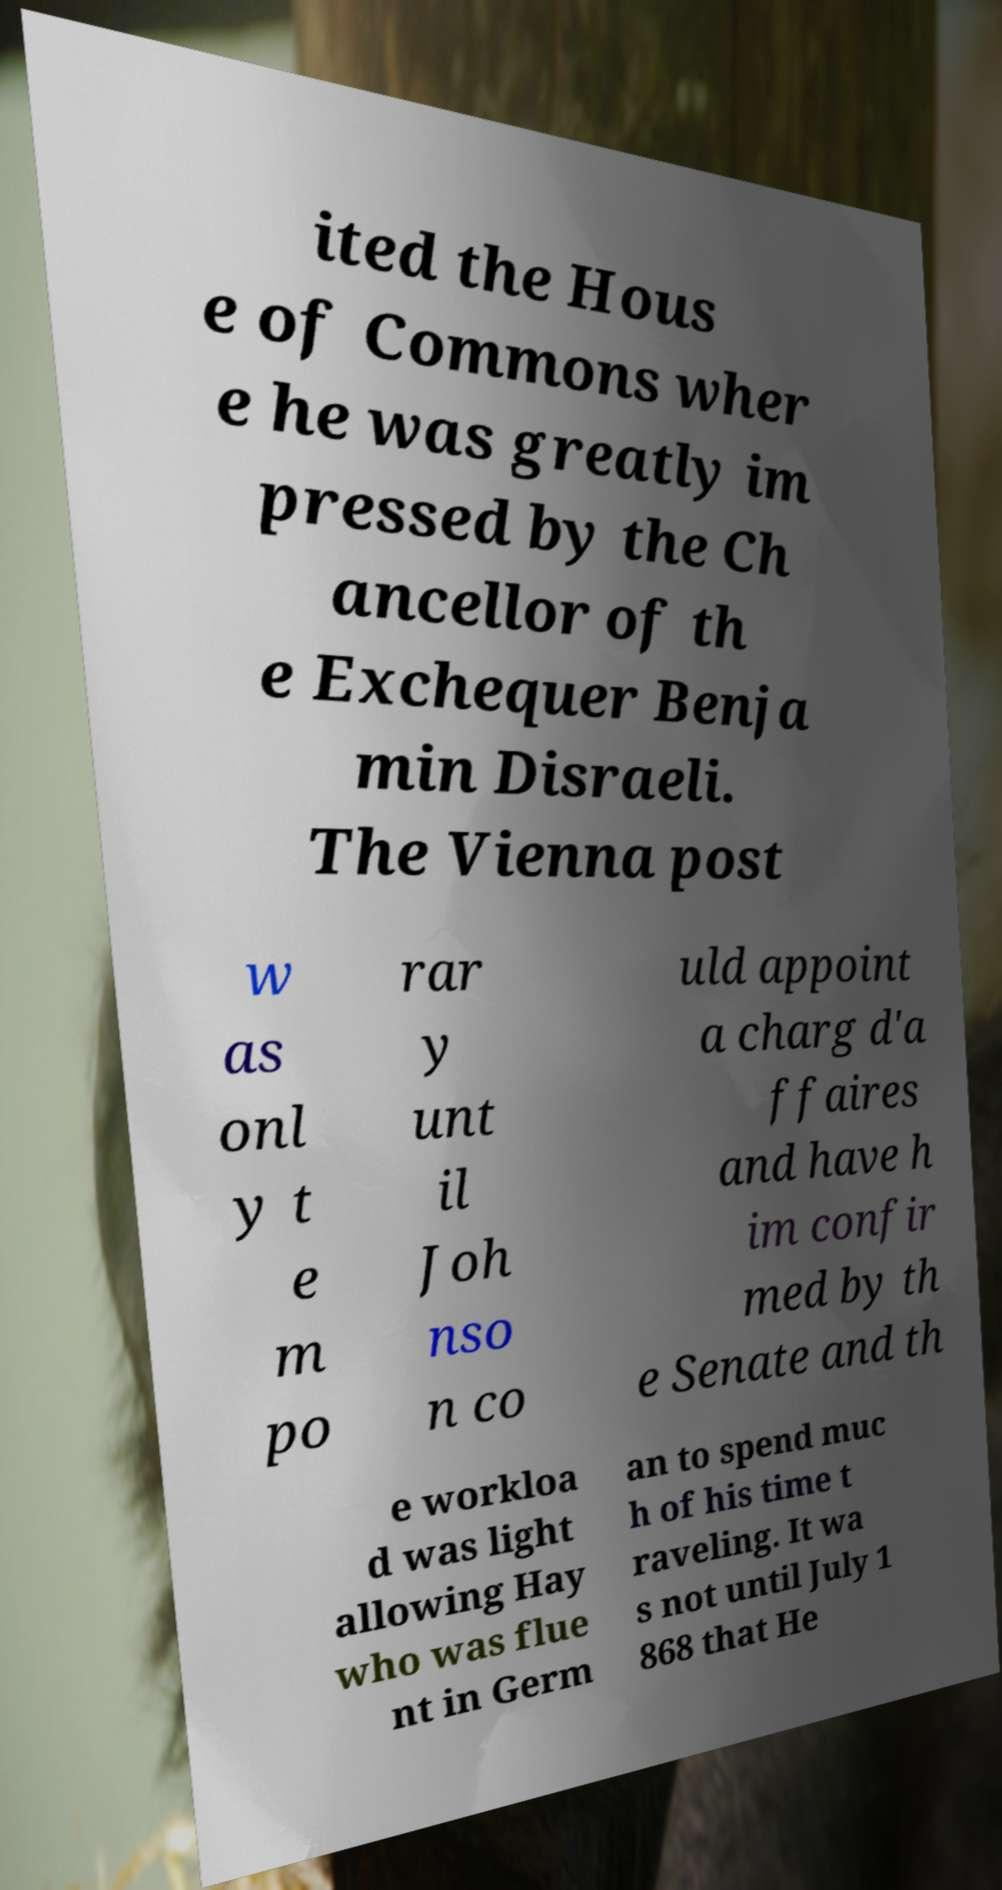What messages or text are displayed in this image? I need them in a readable, typed format. ited the Hous e of Commons wher e he was greatly im pressed by the Ch ancellor of th e Exchequer Benja min Disraeli. The Vienna post w as onl y t e m po rar y unt il Joh nso n co uld appoint a charg d'a ffaires and have h im confir med by th e Senate and th e workloa d was light allowing Hay who was flue nt in Germ an to spend muc h of his time t raveling. It wa s not until July 1 868 that He 